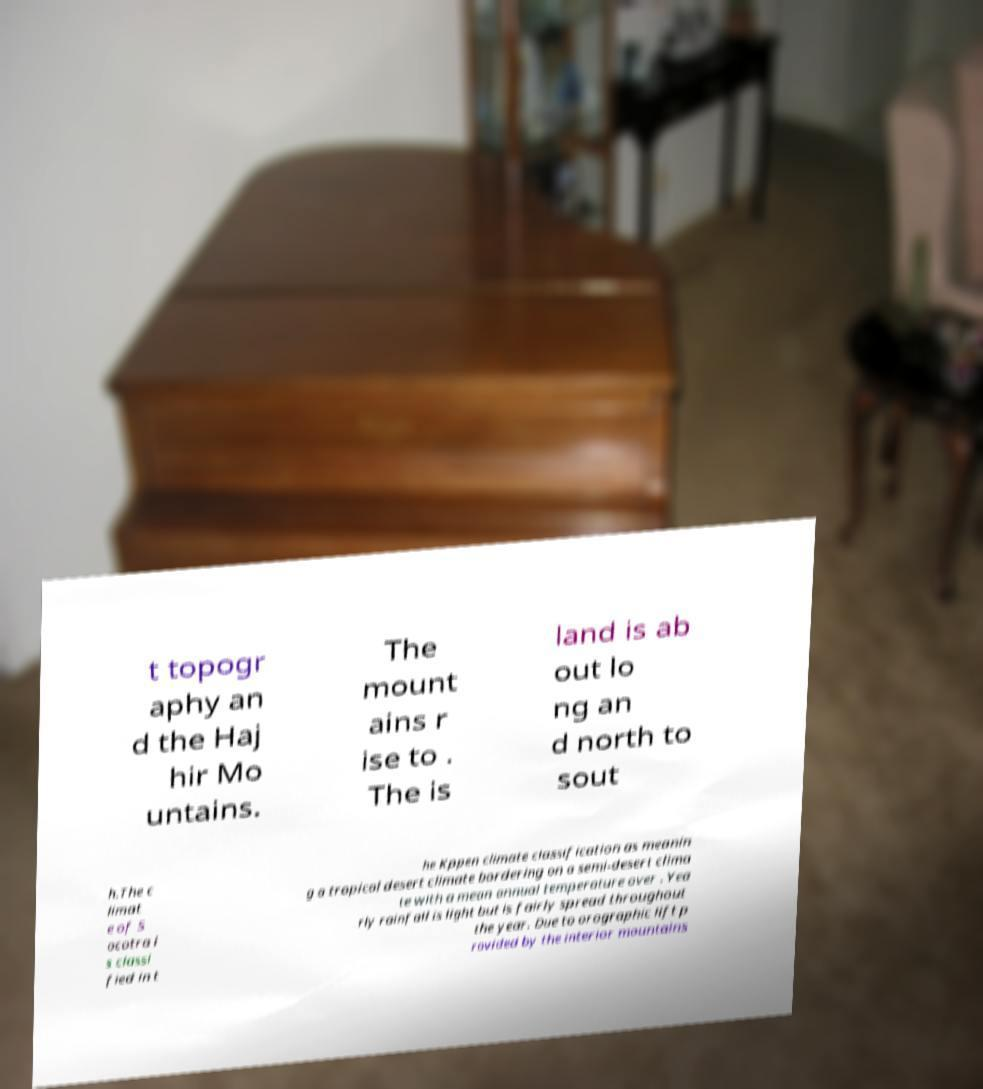For documentation purposes, I need the text within this image transcribed. Could you provide that? t topogr aphy an d the Haj hir Mo untains. The mount ains r ise to . The is land is ab out lo ng an d north to sout h.The c limat e of S ocotra i s classi fied in t he Kppen climate classification as meanin g a tropical desert climate bordering on a semi-desert clima te with a mean annual temperature over . Yea rly rainfall is light but is fairly spread throughout the year. Due to orographic lift p rovided by the interior mountains 